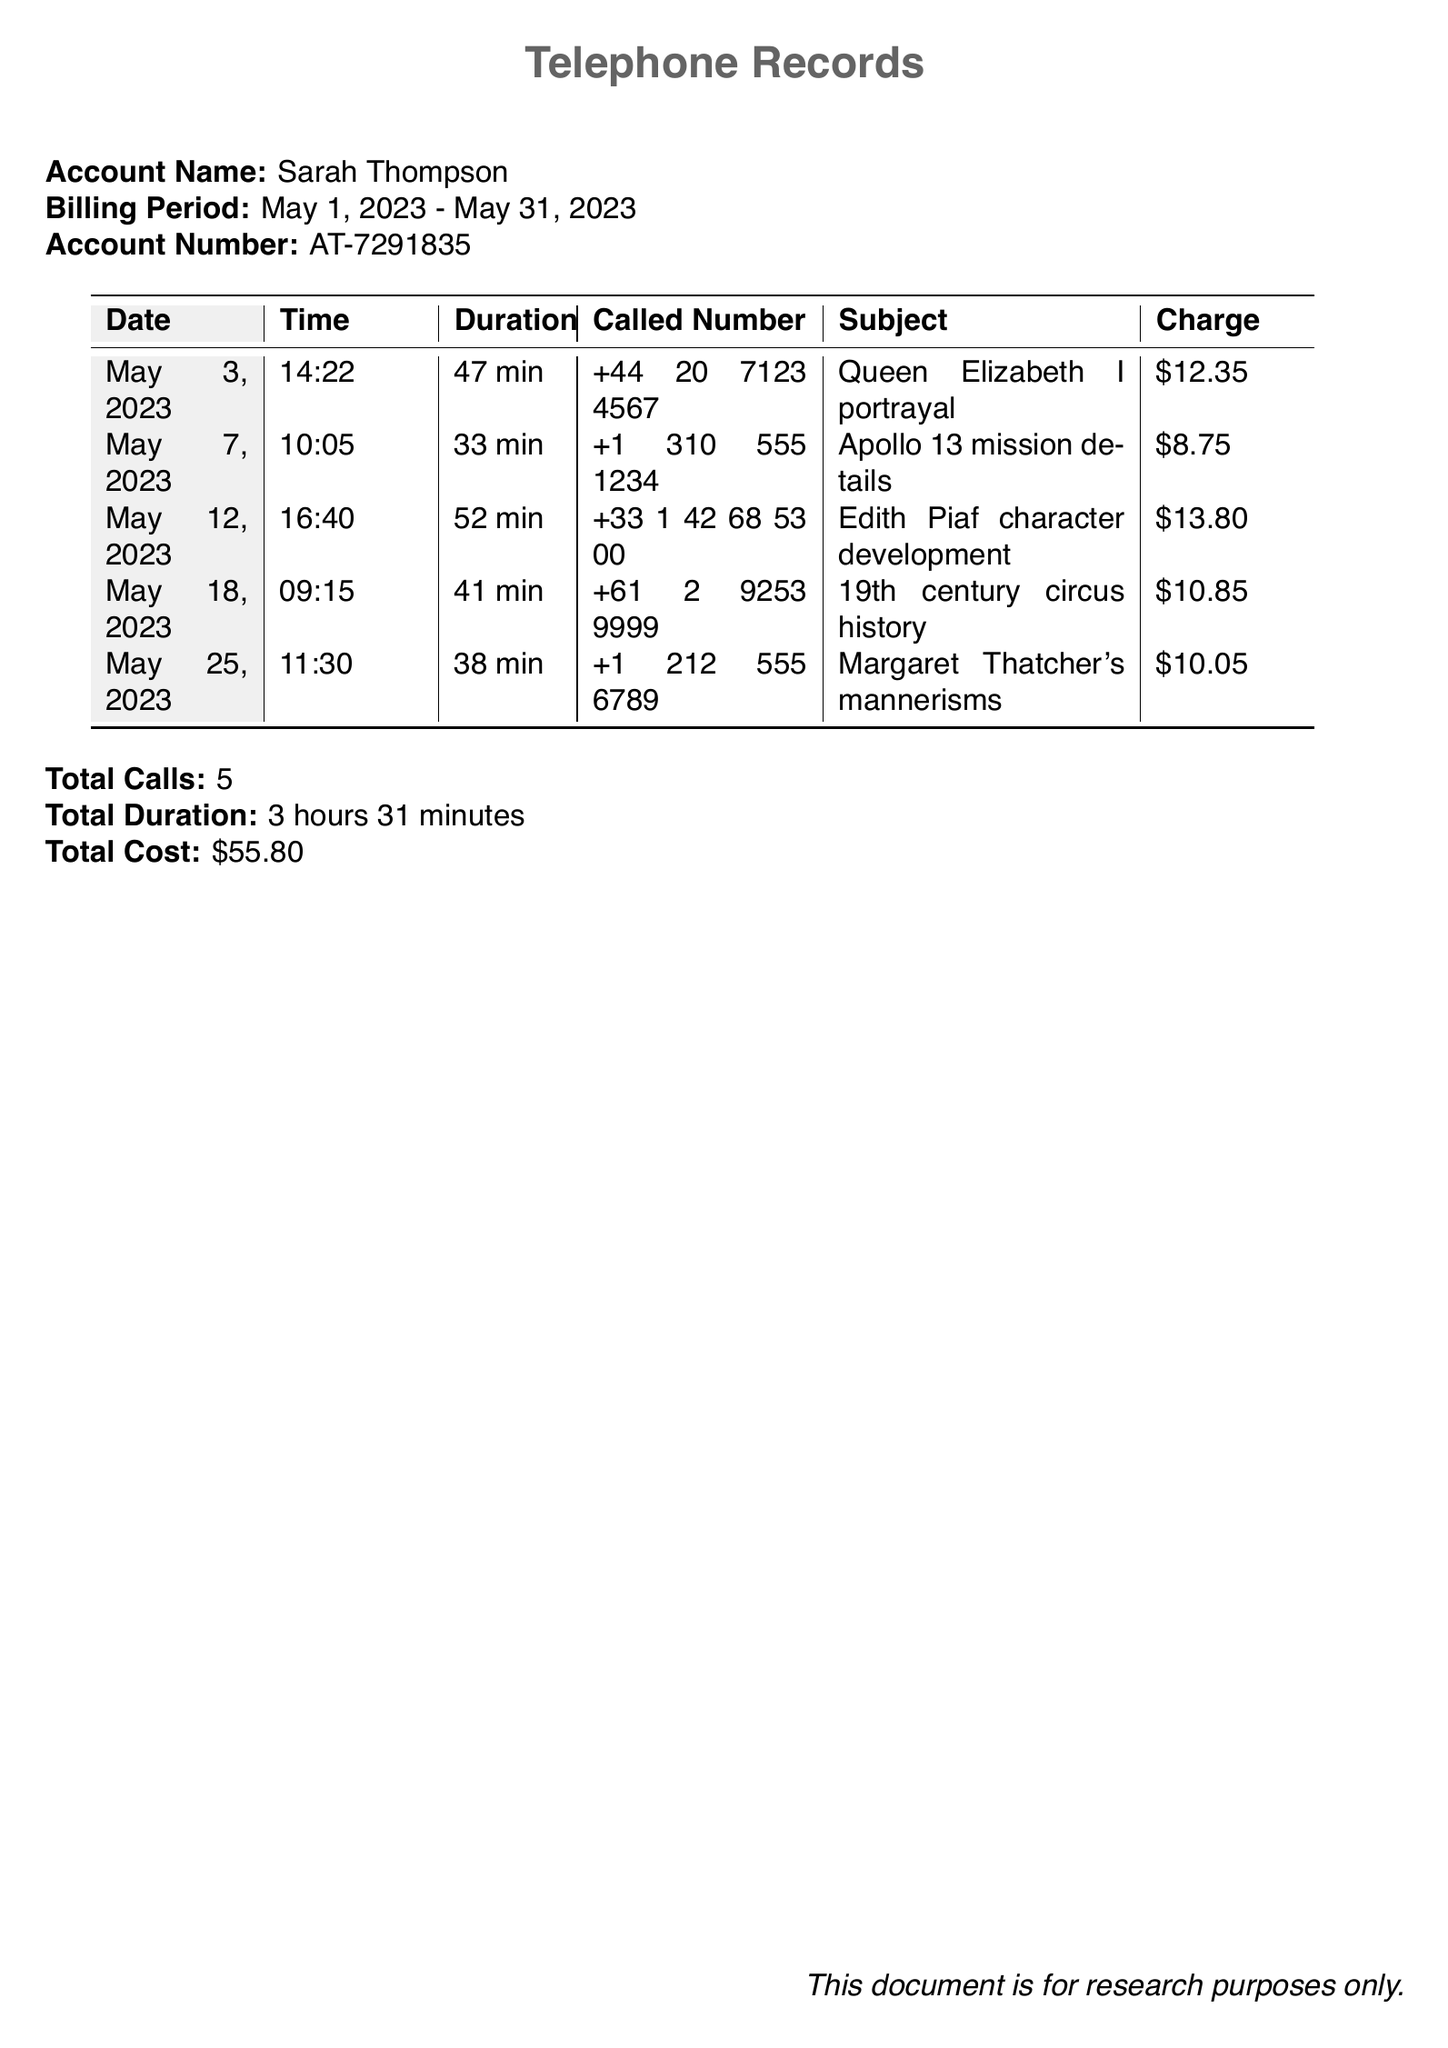What is the account name? The account name is specified at the top of the document under 'Account Name.'
Answer: Sarah Thompson What is the billing period? The billing period is mentioned directly following the account name.
Answer: May 1, 2023 - May 31, 2023 How many total calls are listed? The total calls are noted at the bottom of the document after the call details.
Answer: 5 What was the charge for the call about Queen Elizabeth I portrayal? The charge for this specific call is found in the table alongside the relevant details.
Answer: $12.35 Which character's development was discussed on May 12, 2023? This information is based on the subject noted in the table for that date.
Answer: Edith Piaf character development What is the total duration of all calls combined? This total is summarized at the bottom of the document.
Answer: 3 hours 31 minutes What was the subject of the call on May 18, 2023? The subject is available in the subject column for that date in the table.
Answer: 19th century circus history Which call had the highest charge? This requires comparing all charges listed in the document to identify the highest one.
Answer: $13.80 What time was the call regarding Apollo 13 mission details made? The time is outlined in the relevant row of the table for that call.
Answer: 10:05 